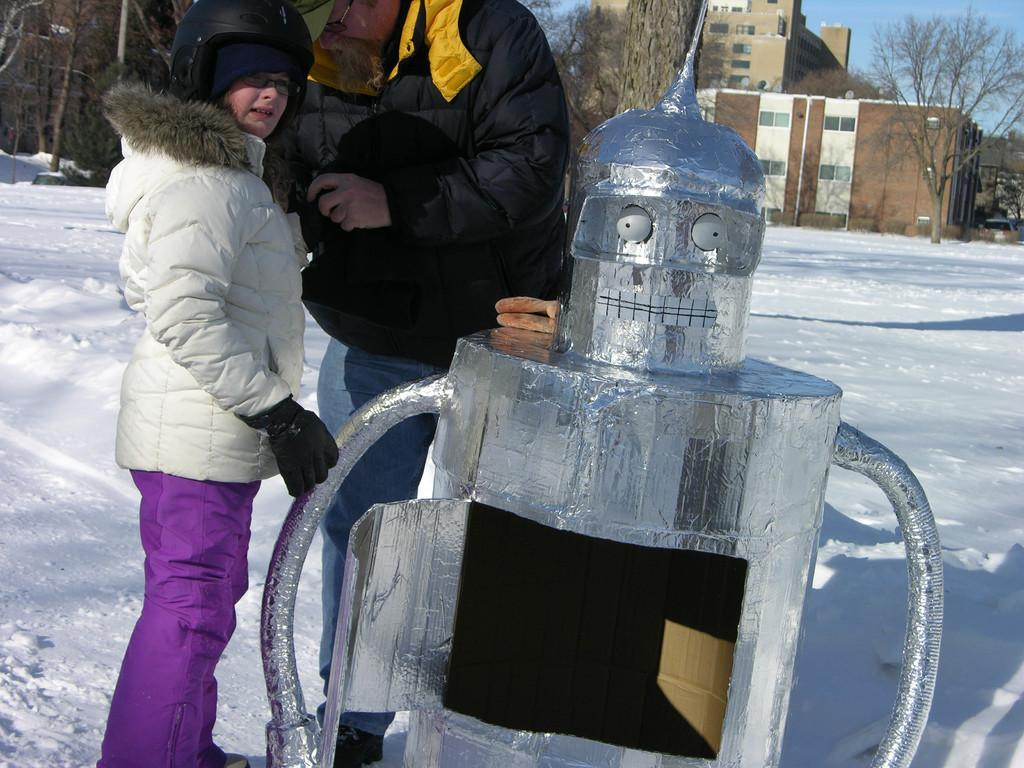What is the condition of the ground in the image? There is snow on the ground in the image. How many persons are visible in the image? There are two persons standing in the image. What is the silver-colored object in front of the persons? The silver-colored object is not specified in the facts provided. What can be seen in the background of the image? There are trees, buildings, and the sky visible in the background of the image. What type of education can be seen taking place in the image? There is no indication of any educational activity in the image. What kind of apparatus is being used by the birds in the image? There are no birds or apparatus present in the image. 